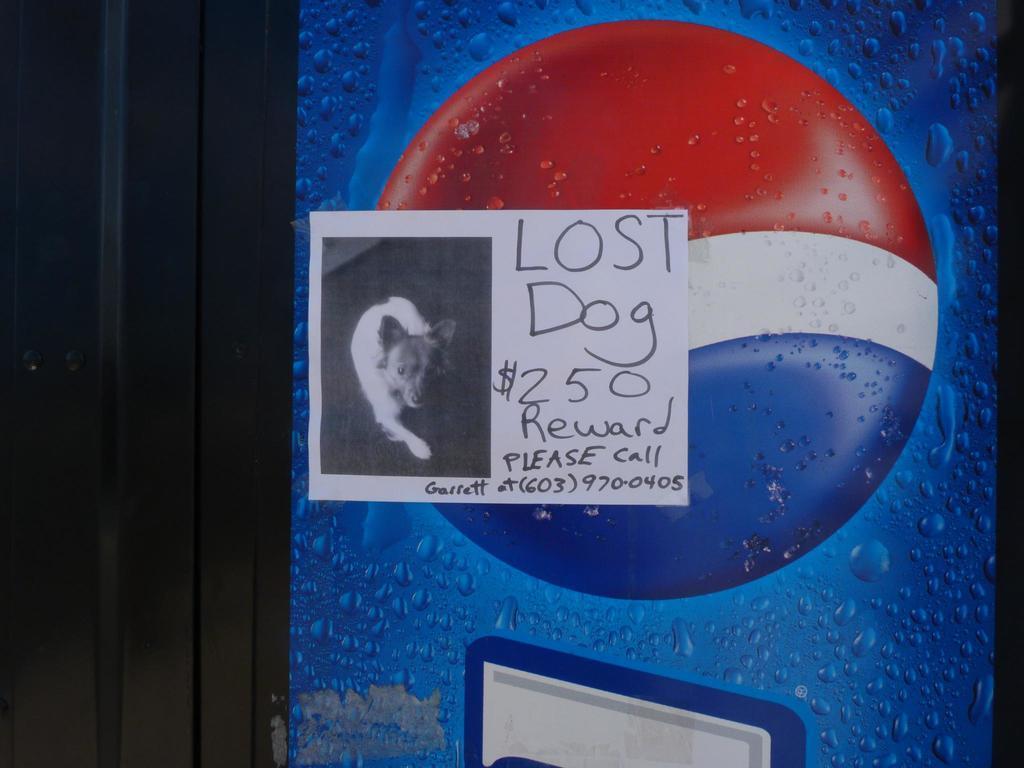Can you describe this image briefly? In the center of the picture there is a poster, on the poster there is a dog and there is text. In this picture there is pepsi logo and there is a door. 